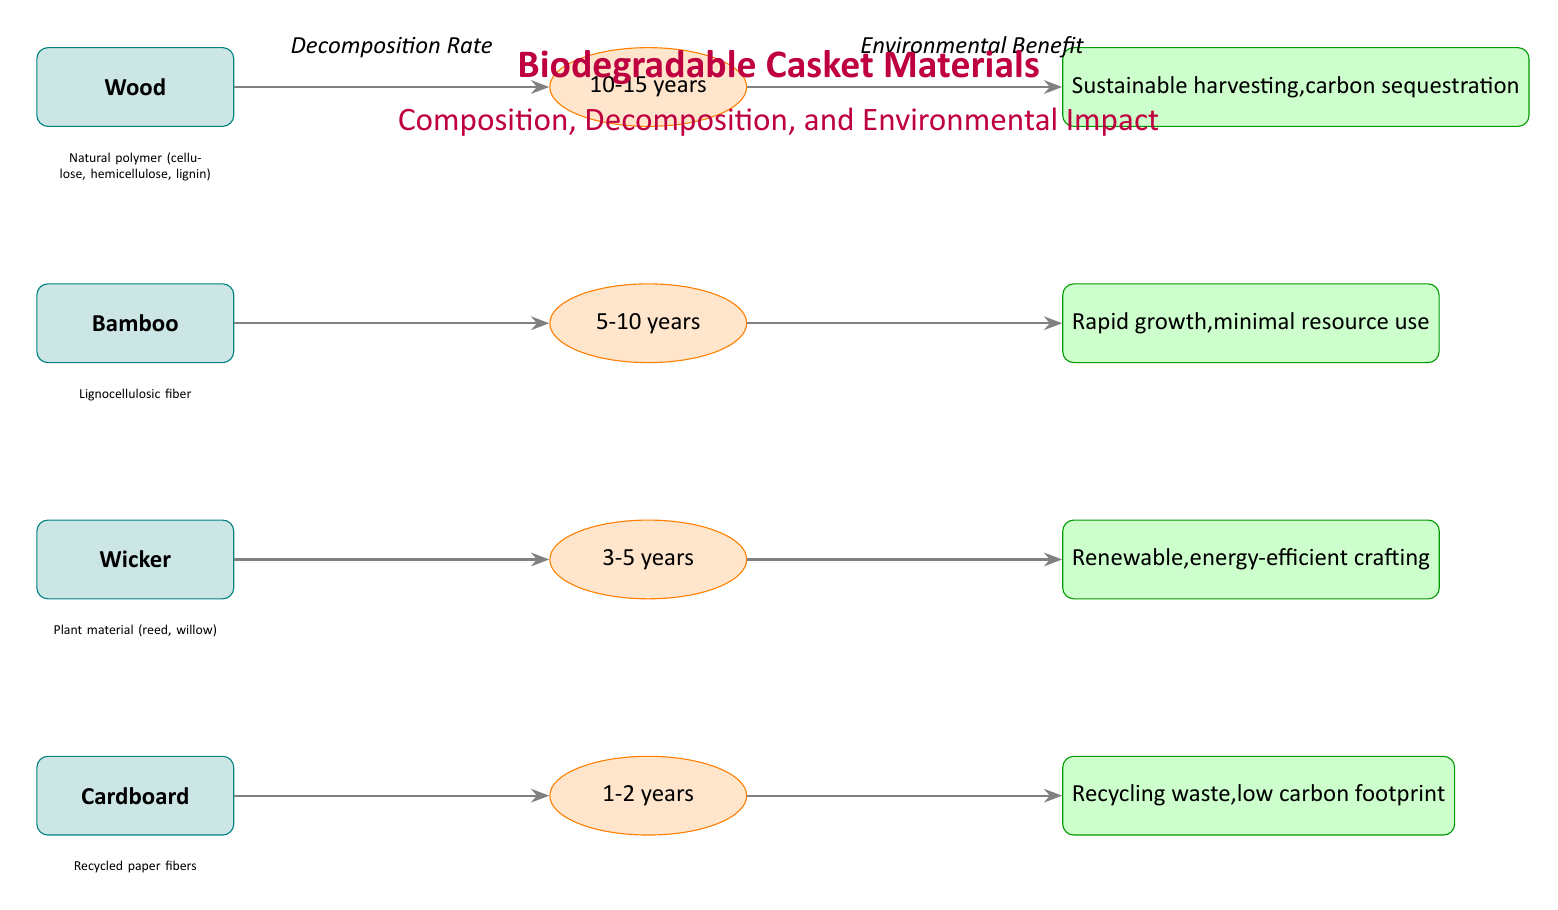What is the decomposition rate of cardboard? The decomposition rate is indicated directly next to the cardboard node in the diagram. It states that cardboard decomposes in 1-2 years.
Answer: 1-2 years Which material has the longest decomposition rate? To find the longest decomposition rate, we compare the values listed next to each material. Wood is the only material that has the longest time, which ranges from 10-15 years.
Answer: Wood What are the environmental benefits of using bamboo? The environmental benefits for bamboo are summarized in the green benefit node connected to it. It states that bamboo has rapid growth and minimal resource use.
Answer: Rapid growth, minimal resource use Is wicker made from natural plant materials? The composition details for wicker are described below the wicker material node and specify "Plant material (reed, willow)", which confirms it is made from natural materials.
Answer: Yes How many materials are compared in the diagram? By counting the material nodes visible in the diagram, there are four distinct materials listed: wood, bamboo, wicker, and cardboard. This provides the total.
Answer: 4 Which biodegradable material has the shortest decomposition time? The decomposition rates indicate cardboard decomposes the fastest, as it decomposes in 1-2 years, while all other materials take longer.
Answer: Cardboard What type of material is used for cardboard caskets? The diagram provides specific details under the cardboard node, explicitly stating that cardboard is made from "Recycled paper fibers," which is the type of material used.
Answer: Recycled paper fibers Which biodegradable material focuses on sustainable harvesting and carbon sequestration? The environmental benefits node next to wood specifically states "Sustainable harvesting, carbon sequestration," linking these benefits directly to wood.
Answer: Wood What key feature does wicker crafting emphasize according to the diagram? Looking at the green benefits node connected to wicker, it emphasizes that wicker is renewable and energy-efficient in its crafting process.
Answer: Renewable, energy-efficient crafting 